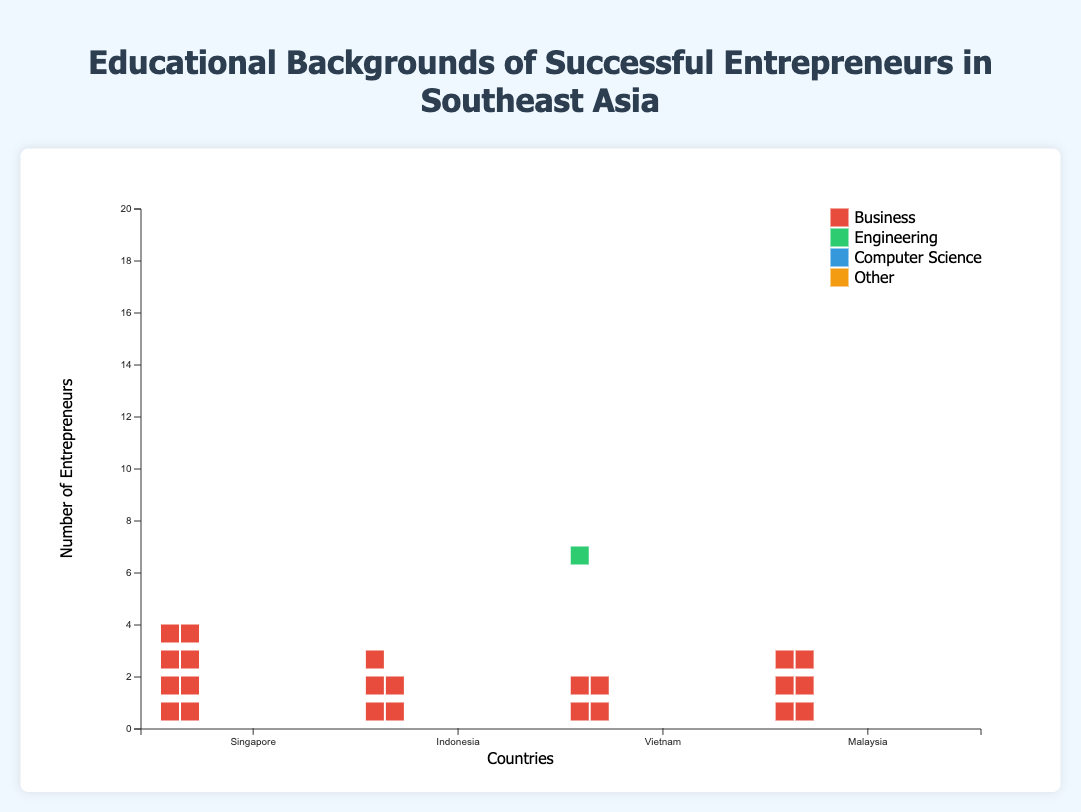What is the title of the chart? The title is displayed at the top of the chart and reads "Educational Backgrounds of Successful Entrepreneurs in Southeast Asia."
Answer: Educational Backgrounds of Successful Entrepreneurs in Southeast Asia Which country has the highest number of entrepreneurs with an education in Business? By examining the Isotype Plot, Singapore has the tallest column for Business education, with 8 entrepreneurs.
Answer: Singapore How many entrepreneurs in Malaysia have a background in Computer Science? By referring to the Malaysia section of the chart, the column for Computer Science education shows 3 icons.
Answer: 3 In Vietnam, which educational background has the highest number of entrepreneurs? Looking at the Vietnam section, Engineering has the tallest column with 5 entrepreneurs.
Answer: Engineering What is the total number of entrepreneurs in Singapore? Sum all the counts for different education backgrounds in Singapore: 8 (Business) + 6 (Engineering) + 4 (Computer Science) + 2 (Other) = 20.
Answer: 20 What is the difference between the number of entrepreneurs with an education in Engineering in Malaysia and Indonesia? The plot shows Malaysia has 4 entrepreneurs in Engineering and Indonesia has 3. The difference is 4 - 3 = 1.
Answer: 1 Which country has the lowest number of entrepreneurs with an education in Other fields? By comparing all columns for "Other," Singapore has the lowest count with 2 entrepreneurs.
Answer: Singapore How does the number of entrepreneurs with a Computer Science background in Vietnam compare to those in Indonesia? Vietnam has 3 entrepreneurs with a Computer Science background while Indonesia has 2. Comparing these, Vietnam has 1 more than Indonesia.
Answer: 1 more Out of all the countries, where do entrepreneurs with a Business background dominate the most? Singapore shows the highest number of entrepreneurs with a Business background compared to other educational backgrounds within the same country (8 entrepreneurs).
Answer: Singapore 